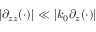Convert formula to latex. <formula><loc_0><loc_0><loc_500><loc_500>| \partial _ { z z } ( \cdot ) | \ll | k _ { 0 } \partial _ { z } ( \cdot ) |</formula> 